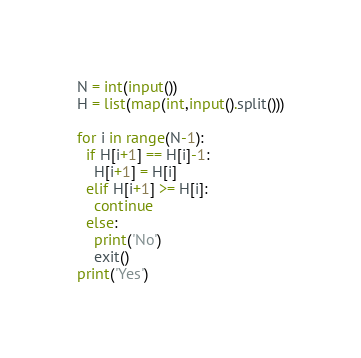<code> <loc_0><loc_0><loc_500><loc_500><_Python_>N = int(input())
H = list(map(int,input().split()))

for i in range(N-1):
  if H[i+1] == H[i]-1:
    H[i+1] = H[i]
  elif H[i+1] >= H[i]:
    continue
  else:
    print('No')
    exit()
print('Yes')</code> 